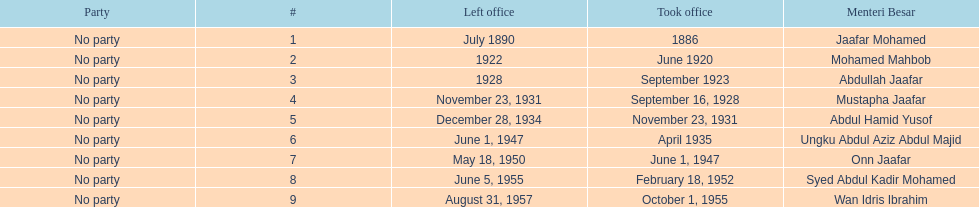Who was in office after mustapha jaafar Abdul Hamid Yusof. 